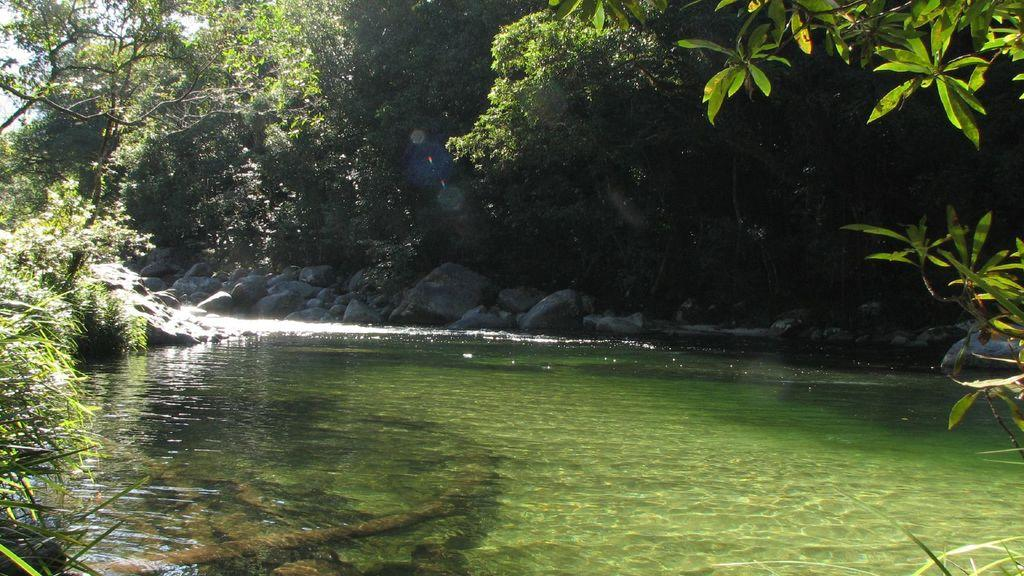What is the primary element visible in the image? There is water in the image. What type of natural vegetation can be seen in the image? There are trees in the image. What other objects or features are present in the image? There are rocks in the image. What type of fruit is hanging from the trees in the image? There is no fruit visible in the image; only trees and rocks are present. 